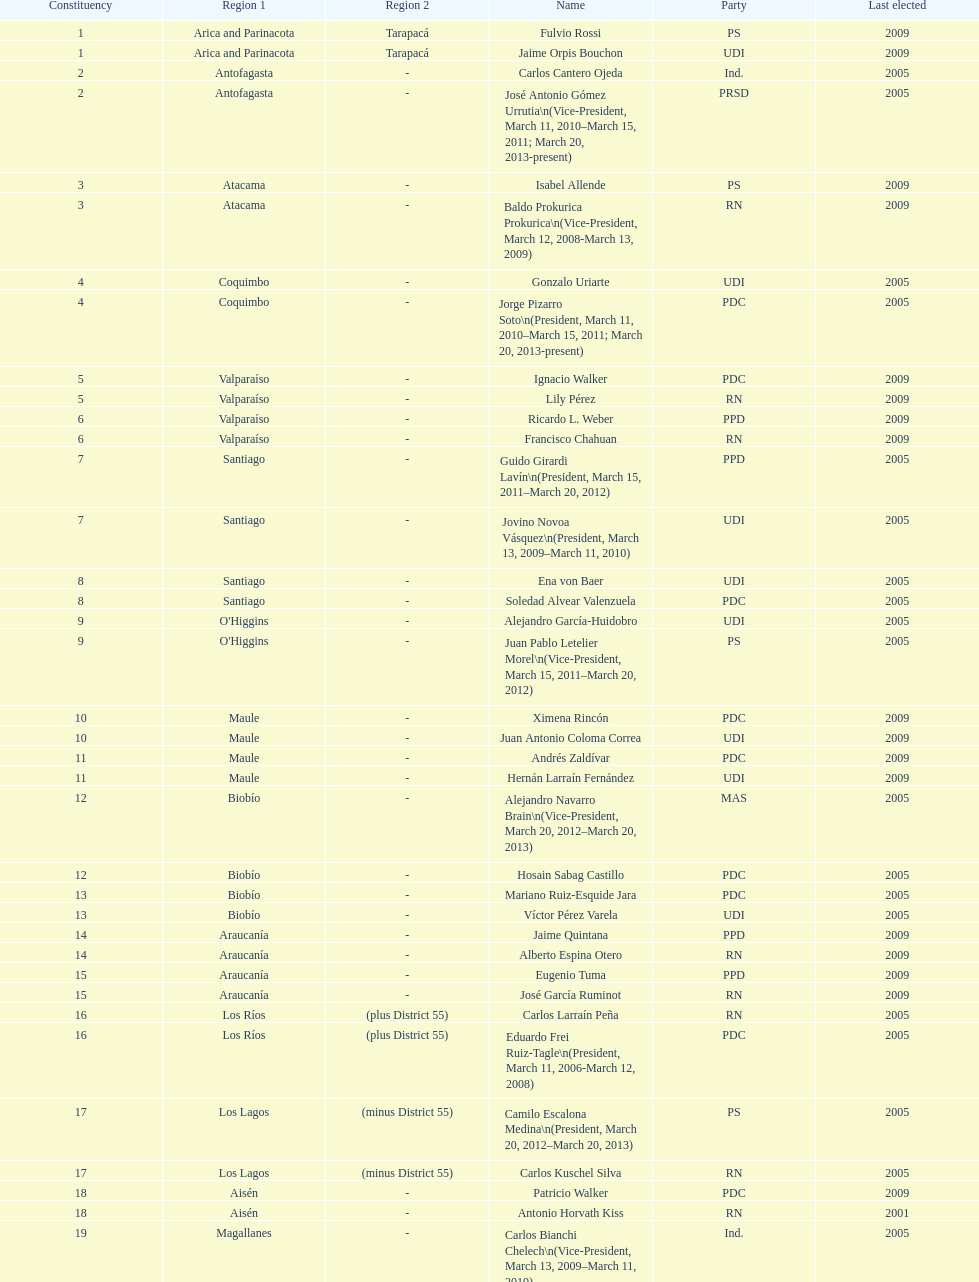Who was not last elected in either 2005 or 2009? Antonio Horvath Kiss. 